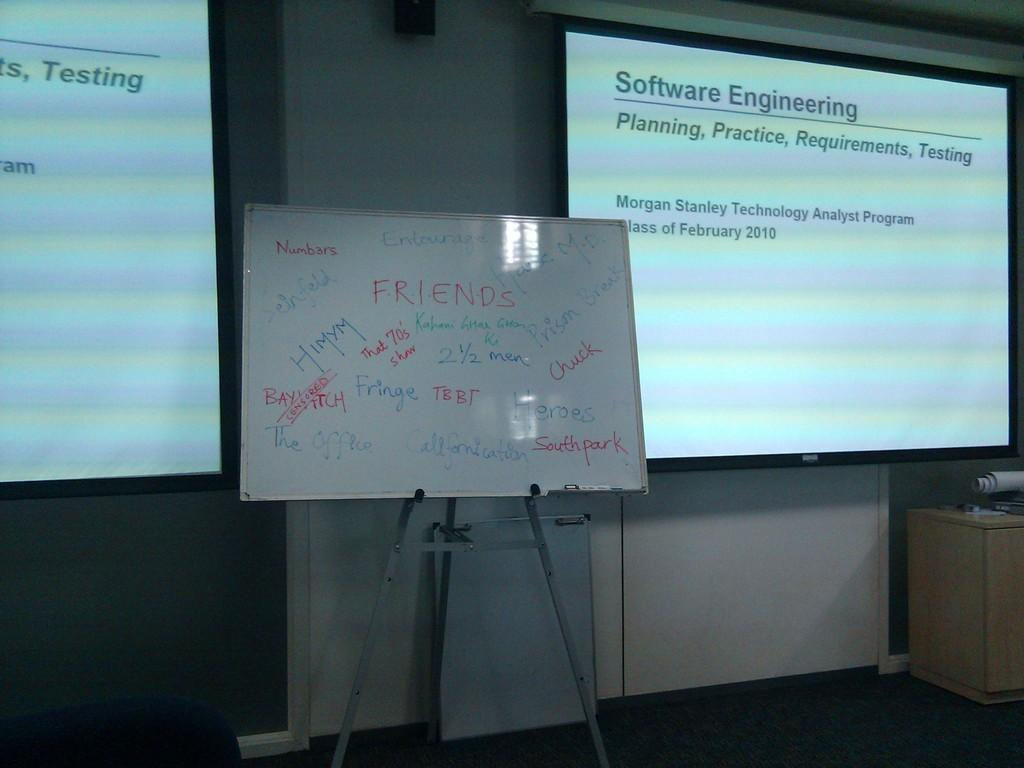<image>
Present a compact description of the photo's key features. the word software that is on a power point presentation 